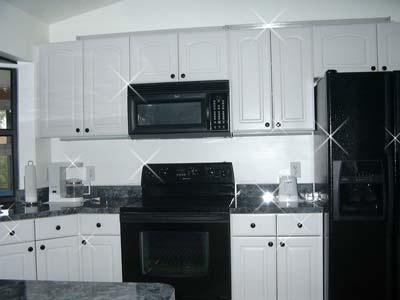What room is this?
Write a very short answer. Kitchen. What color is the refrigerator?
Write a very short answer. Black. Do the upper and lower cabinets line up?
Concise answer only. Yes. Are the cabinets brown?
Give a very brief answer. No. What type of range is this?
Short answer required. Electric. What color are the appliances?
Keep it brief. Black. 